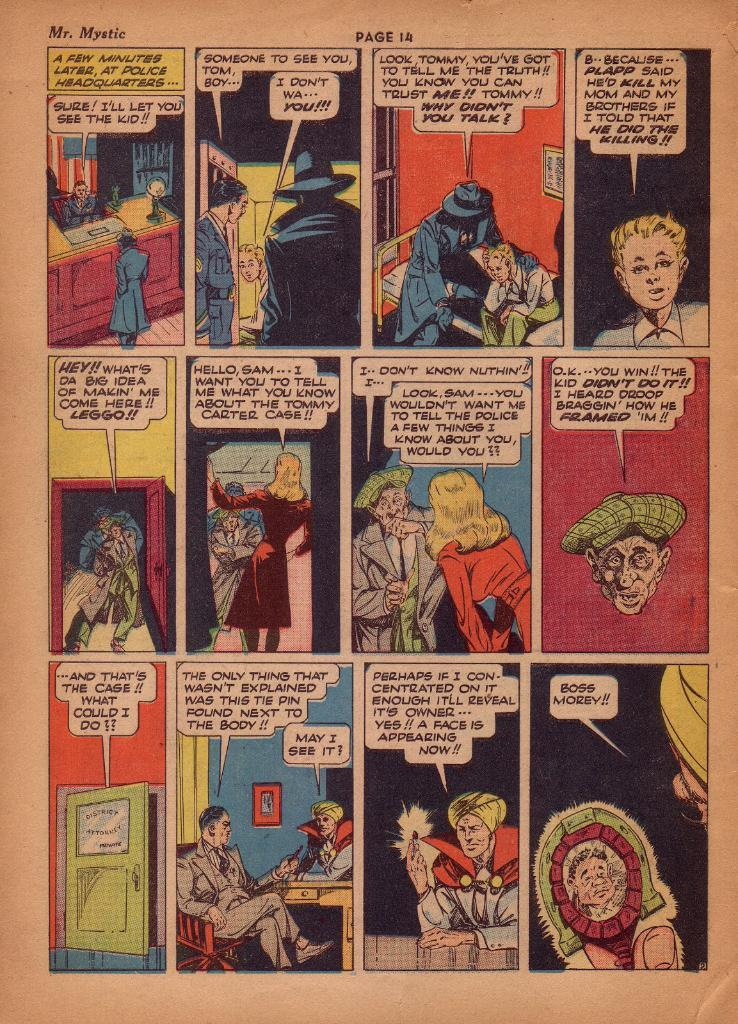<image>
Provide a brief description of the given image. Comic book reading that is about Mr. Mystic on Page 14. 